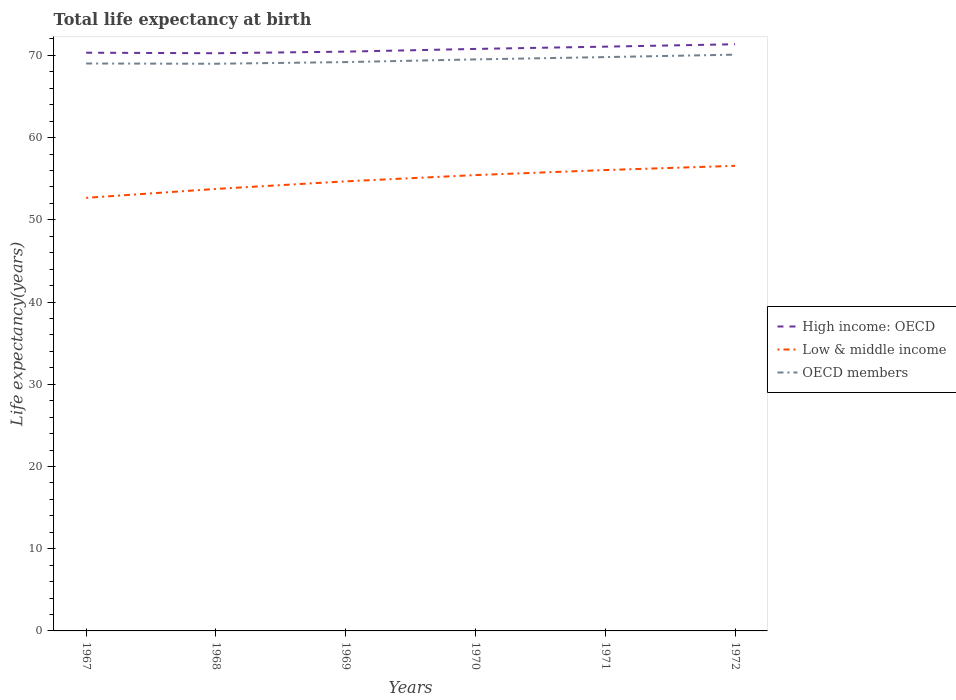Does the line corresponding to Low & middle income intersect with the line corresponding to OECD members?
Offer a terse response. No. Is the number of lines equal to the number of legend labels?
Give a very brief answer. Yes. Across all years, what is the maximum life expectancy at birth in in High income: OECD?
Your answer should be compact. 70.26. In which year was the life expectancy at birth in in OECD members maximum?
Give a very brief answer. 1968. What is the total life expectancy at birth in in OECD members in the graph?
Offer a very short reply. -0.78. What is the difference between the highest and the second highest life expectancy at birth in in OECD members?
Offer a very short reply. 1.11. What is the difference between the highest and the lowest life expectancy at birth in in Low & middle income?
Offer a terse response. 3. How many years are there in the graph?
Your answer should be compact. 6. Are the values on the major ticks of Y-axis written in scientific E-notation?
Your response must be concise. No. Where does the legend appear in the graph?
Give a very brief answer. Center right. What is the title of the graph?
Provide a succinct answer. Total life expectancy at birth. Does "Benin" appear as one of the legend labels in the graph?
Keep it short and to the point. No. What is the label or title of the Y-axis?
Your answer should be compact. Life expectancy(years). What is the Life expectancy(years) of High income: OECD in 1967?
Offer a terse response. 70.32. What is the Life expectancy(years) of Low & middle income in 1967?
Provide a succinct answer. 52.67. What is the Life expectancy(years) of OECD members in 1967?
Ensure brevity in your answer.  69.01. What is the Life expectancy(years) in High income: OECD in 1968?
Your response must be concise. 70.26. What is the Life expectancy(years) in Low & middle income in 1968?
Keep it short and to the point. 53.76. What is the Life expectancy(years) in OECD members in 1968?
Provide a succinct answer. 68.98. What is the Life expectancy(years) in High income: OECD in 1969?
Your answer should be compact. 70.45. What is the Life expectancy(years) of Low & middle income in 1969?
Provide a succinct answer. 54.68. What is the Life expectancy(years) of OECD members in 1969?
Ensure brevity in your answer.  69.18. What is the Life expectancy(years) of High income: OECD in 1970?
Offer a very short reply. 70.78. What is the Life expectancy(years) in Low & middle income in 1970?
Make the answer very short. 55.44. What is the Life expectancy(years) in OECD members in 1970?
Your answer should be compact. 69.51. What is the Life expectancy(years) in High income: OECD in 1971?
Make the answer very short. 71.06. What is the Life expectancy(years) in Low & middle income in 1971?
Offer a terse response. 56.05. What is the Life expectancy(years) in OECD members in 1971?
Make the answer very short. 69.79. What is the Life expectancy(years) of High income: OECD in 1972?
Your response must be concise. 71.35. What is the Life expectancy(years) of Low & middle income in 1972?
Your response must be concise. 56.57. What is the Life expectancy(years) of OECD members in 1972?
Provide a succinct answer. 70.09. Across all years, what is the maximum Life expectancy(years) of High income: OECD?
Make the answer very short. 71.35. Across all years, what is the maximum Life expectancy(years) in Low & middle income?
Your response must be concise. 56.57. Across all years, what is the maximum Life expectancy(years) of OECD members?
Provide a short and direct response. 70.09. Across all years, what is the minimum Life expectancy(years) of High income: OECD?
Your answer should be compact. 70.26. Across all years, what is the minimum Life expectancy(years) of Low & middle income?
Provide a succinct answer. 52.67. Across all years, what is the minimum Life expectancy(years) of OECD members?
Give a very brief answer. 68.98. What is the total Life expectancy(years) in High income: OECD in the graph?
Your answer should be very brief. 424.23. What is the total Life expectancy(years) in Low & middle income in the graph?
Give a very brief answer. 329.16. What is the total Life expectancy(years) in OECD members in the graph?
Make the answer very short. 416.56. What is the difference between the Life expectancy(years) in High income: OECD in 1967 and that in 1968?
Your answer should be very brief. 0.06. What is the difference between the Life expectancy(years) in Low & middle income in 1967 and that in 1968?
Your response must be concise. -1.08. What is the difference between the Life expectancy(years) of OECD members in 1967 and that in 1968?
Your response must be concise. 0.03. What is the difference between the Life expectancy(years) of High income: OECD in 1967 and that in 1969?
Provide a succinct answer. -0.13. What is the difference between the Life expectancy(years) in Low & middle income in 1967 and that in 1969?
Offer a very short reply. -2. What is the difference between the Life expectancy(years) in OECD members in 1967 and that in 1969?
Give a very brief answer. -0.17. What is the difference between the Life expectancy(years) of High income: OECD in 1967 and that in 1970?
Provide a short and direct response. -0.46. What is the difference between the Life expectancy(years) in Low & middle income in 1967 and that in 1970?
Provide a short and direct response. -2.77. What is the difference between the Life expectancy(years) in OECD members in 1967 and that in 1970?
Ensure brevity in your answer.  -0.5. What is the difference between the Life expectancy(years) of High income: OECD in 1967 and that in 1971?
Provide a succinct answer. -0.74. What is the difference between the Life expectancy(years) of Low & middle income in 1967 and that in 1971?
Your answer should be compact. -3.38. What is the difference between the Life expectancy(years) in OECD members in 1967 and that in 1971?
Make the answer very short. -0.78. What is the difference between the Life expectancy(years) in High income: OECD in 1967 and that in 1972?
Provide a short and direct response. -1.03. What is the difference between the Life expectancy(years) in Low & middle income in 1967 and that in 1972?
Provide a short and direct response. -3.89. What is the difference between the Life expectancy(years) of OECD members in 1967 and that in 1972?
Keep it short and to the point. -1.07. What is the difference between the Life expectancy(years) in High income: OECD in 1968 and that in 1969?
Provide a succinct answer. -0.19. What is the difference between the Life expectancy(years) of Low & middle income in 1968 and that in 1969?
Your answer should be compact. -0.92. What is the difference between the Life expectancy(years) of OECD members in 1968 and that in 1969?
Provide a short and direct response. -0.2. What is the difference between the Life expectancy(years) of High income: OECD in 1968 and that in 1970?
Keep it short and to the point. -0.52. What is the difference between the Life expectancy(years) of Low & middle income in 1968 and that in 1970?
Make the answer very short. -1.69. What is the difference between the Life expectancy(years) of OECD members in 1968 and that in 1970?
Keep it short and to the point. -0.53. What is the difference between the Life expectancy(years) of High income: OECD in 1968 and that in 1971?
Provide a short and direct response. -0.8. What is the difference between the Life expectancy(years) in Low & middle income in 1968 and that in 1971?
Your answer should be very brief. -2.3. What is the difference between the Life expectancy(years) of OECD members in 1968 and that in 1971?
Ensure brevity in your answer.  -0.81. What is the difference between the Life expectancy(years) of High income: OECD in 1968 and that in 1972?
Provide a succinct answer. -1.09. What is the difference between the Life expectancy(years) of Low & middle income in 1968 and that in 1972?
Ensure brevity in your answer.  -2.81. What is the difference between the Life expectancy(years) in OECD members in 1968 and that in 1972?
Provide a succinct answer. -1.11. What is the difference between the Life expectancy(years) of High income: OECD in 1969 and that in 1970?
Keep it short and to the point. -0.33. What is the difference between the Life expectancy(years) in Low & middle income in 1969 and that in 1970?
Offer a terse response. -0.76. What is the difference between the Life expectancy(years) in OECD members in 1969 and that in 1970?
Offer a terse response. -0.33. What is the difference between the Life expectancy(years) in High income: OECD in 1969 and that in 1971?
Ensure brevity in your answer.  -0.61. What is the difference between the Life expectancy(years) of Low & middle income in 1969 and that in 1971?
Provide a short and direct response. -1.37. What is the difference between the Life expectancy(years) in OECD members in 1969 and that in 1971?
Make the answer very short. -0.61. What is the difference between the Life expectancy(years) of High income: OECD in 1969 and that in 1972?
Give a very brief answer. -0.9. What is the difference between the Life expectancy(years) of Low & middle income in 1969 and that in 1972?
Keep it short and to the point. -1.89. What is the difference between the Life expectancy(years) of OECD members in 1969 and that in 1972?
Ensure brevity in your answer.  -0.9. What is the difference between the Life expectancy(years) of High income: OECD in 1970 and that in 1971?
Provide a succinct answer. -0.28. What is the difference between the Life expectancy(years) of Low & middle income in 1970 and that in 1971?
Offer a very short reply. -0.61. What is the difference between the Life expectancy(years) in OECD members in 1970 and that in 1971?
Your response must be concise. -0.28. What is the difference between the Life expectancy(years) of High income: OECD in 1970 and that in 1972?
Offer a terse response. -0.57. What is the difference between the Life expectancy(years) in Low & middle income in 1970 and that in 1972?
Make the answer very short. -1.12. What is the difference between the Life expectancy(years) of OECD members in 1970 and that in 1972?
Make the answer very short. -0.58. What is the difference between the Life expectancy(years) in High income: OECD in 1971 and that in 1972?
Provide a succinct answer. -0.29. What is the difference between the Life expectancy(years) of Low & middle income in 1971 and that in 1972?
Ensure brevity in your answer.  -0.51. What is the difference between the Life expectancy(years) in OECD members in 1971 and that in 1972?
Keep it short and to the point. -0.3. What is the difference between the Life expectancy(years) of High income: OECD in 1967 and the Life expectancy(years) of Low & middle income in 1968?
Offer a very short reply. 16.57. What is the difference between the Life expectancy(years) of High income: OECD in 1967 and the Life expectancy(years) of OECD members in 1968?
Give a very brief answer. 1.34. What is the difference between the Life expectancy(years) in Low & middle income in 1967 and the Life expectancy(years) in OECD members in 1968?
Give a very brief answer. -16.31. What is the difference between the Life expectancy(years) in High income: OECD in 1967 and the Life expectancy(years) in Low & middle income in 1969?
Ensure brevity in your answer.  15.65. What is the difference between the Life expectancy(years) in High income: OECD in 1967 and the Life expectancy(years) in OECD members in 1969?
Keep it short and to the point. 1.14. What is the difference between the Life expectancy(years) of Low & middle income in 1967 and the Life expectancy(years) of OECD members in 1969?
Offer a very short reply. -16.51. What is the difference between the Life expectancy(years) of High income: OECD in 1967 and the Life expectancy(years) of Low & middle income in 1970?
Your answer should be very brief. 14.88. What is the difference between the Life expectancy(years) in High income: OECD in 1967 and the Life expectancy(years) in OECD members in 1970?
Make the answer very short. 0.81. What is the difference between the Life expectancy(years) in Low & middle income in 1967 and the Life expectancy(years) in OECD members in 1970?
Your answer should be very brief. -16.84. What is the difference between the Life expectancy(years) in High income: OECD in 1967 and the Life expectancy(years) in Low & middle income in 1971?
Ensure brevity in your answer.  14.27. What is the difference between the Life expectancy(years) of High income: OECD in 1967 and the Life expectancy(years) of OECD members in 1971?
Keep it short and to the point. 0.53. What is the difference between the Life expectancy(years) of Low & middle income in 1967 and the Life expectancy(years) of OECD members in 1971?
Make the answer very short. -17.12. What is the difference between the Life expectancy(years) of High income: OECD in 1967 and the Life expectancy(years) of Low & middle income in 1972?
Give a very brief answer. 13.76. What is the difference between the Life expectancy(years) in High income: OECD in 1967 and the Life expectancy(years) in OECD members in 1972?
Provide a succinct answer. 0.24. What is the difference between the Life expectancy(years) of Low & middle income in 1967 and the Life expectancy(years) of OECD members in 1972?
Provide a short and direct response. -17.41. What is the difference between the Life expectancy(years) in High income: OECD in 1968 and the Life expectancy(years) in Low & middle income in 1969?
Your response must be concise. 15.58. What is the difference between the Life expectancy(years) in High income: OECD in 1968 and the Life expectancy(years) in OECD members in 1969?
Offer a very short reply. 1.08. What is the difference between the Life expectancy(years) in Low & middle income in 1968 and the Life expectancy(years) in OECD members in 1969?
Your answer should be compact. -15.43. What is the difference between the Life expectancy(years) of High income: OECD in 1968 and the Life expectancy(years) of Low & middle income in 1970?
Your answer should be compact. 14.82. What is the difference between the Life expectancy(years) of High income: OECD in 1968 and the Life expectancy(years) of OECD members in 1970?
Your response must be concise. 0.75. What is the difference between the Life expectancy(years) of Low & middle income in 1968 and the Life expectancy(years) of OECD members in 1970?
Ensure brevity in your answer.  -15.75. What is the difference between the Life expectancy(years) in High income: OECD in 1968 and the Life expectancy(years) in Low & middle income in 1971?
Provide a succinct answer. 14.21. What is the difference between the Life expectancy(years) of High income: OECD in 1968 and the Life expectancy(years) of OECD members in 1971?
Give a very brief answer. 0.47. What is the difference between the Life expectancy(years) in Low & middle income in 1968 and the Life expectancy(years) in OECD members in 1971?
Keep it short and to the point. -16.03. What is the difference between the Life expectancy(years) in High income: OECD in 1968 and the Life expectancy(years) in Low & middle income in 1972?
Provide a short and direct response. 13.7. What is the difference between the Life expectancy(years) of High income: OECD in 1968 and the Life expectancy(years) of OECD members in 1972?
Offer a very short reply. 0.18. What is the difference between the Life expectancy(years) of Low & middle income in 1968 and the Life expectancy(years) of OECD members in 1972?
Your response must be concise. -16.33. What is the difference between the Life expectancy(years) of High income: OECD in 1969 and the Life expectancy(years) of Low & middle income in 1970?
Offer a very short reply. 15.01. What is the difference between the Life expectancy(years) in High income: OECD in 1969 and the Life expectancy(years) in OECD members in 1970?
Ensure brevity in your answer.  0.94. What is the difference between the Life expectancy(years) of Low & middle income in 1969 and the Life expectancy(years) of OECD members in 1970?
Ensure brevity in your answer.  -14.83. What is the difference between the Life expectancy(years) in High income: OECD in 1969 and the Life expectancy(years) in Low & middle income in 1971?
Your answer should be very brief. 14.4. What is the difference between the Life expectancy(years) in High income: OECD in 1969 and the Life expectancy(years) in OECD members in 1971?
Ensure brevity in your answer.  0.66. What is the difference between the Life expectancy(years) of Low & middle income in 1969 and the Life expectancy(years) of OECD members in 1971?
Keep it short and to the point. -15.11. What is the difference between the Life expectancy(years) in High income: OECD in 1969 and the Life expectancy(years) in Low & middle income in 1972?
Give a very brief answer. 13.89. What is the difference between the Life expectancy(years) in High income: OECD in 1969 and the Life expectancy(years) in OECD members in 1972?
Ensure brevity in your answer.  0.37. What is the difference between the Life expectancy(years) in Low & middle income in 1969 and the Life expectancy(years) in OECD members in 1972?
Give a very brief answer. -15.41. What is the difference between the Life expectancy(years) in High income: OECD in 1970 and the Life expectancy(years) in Low & middle income in 1971?
Give a very brief answer. 14.73. What is the difference between the Life expectancy(years) in Low & middle income in 1970 and the Life expectancy(years) in OECD members in 1971?
Make the answer very short. -14.35. What is the difference between the Life expectancy(years) in High income: OECD in 1970 and the Life expectancy(years) in Low & middle income in 1972?
Give a very brief answer. 14.22. What is the difference between the Life expectancy(years) in High income: OECD in 1970 and the Life expectancy(years) in OECD members in 1972?
Make the answer very short. 0.7. What is the difference between the Life expectancy(years) in Low & middle income in 1970 and the Life expectancy(years) in OECD members in 1972?
Ensure brevity in your answer.  -14.65. What is the difference between the Life expectancy(years) in High income: OECD in 1971 and the Life expectancy(years) in Low & middle income in 1972?
Ensure brevity in your answer.  14.5. What is the difference between the Life expectancy(years) of High income: OECD in 1971 and the Life expectancy(years) of OECD members in 1972?
Your response must be concise. 0.98. What is the difference between the Life expectancy(years) of Low & middle income in 1971 and the Life expectancy(years) of OECD members in 1972?
Give a very brief answer. -14.03. What is the average Life expectancy(years) of High income: OECD per year?
Ensure brevity in your answer.  70.71. What is the average Life expectancy(years) of Low & middle income per year?
Offer a very short reply. 54.86. What is the average Life expectancy(years) in OECD members per year?
Keep it short and to the point. 69.43. In the year 1967, what is the difference between the Life expectancy(years) of High income: OECD and Life expectancy(years) of Low & middle income?
Provide a short and direct response. 17.65. In the year 1967, what is the difference between the Life expectancy(years) of High income: OECD and Life expectancy(years) of OECD members?
Offer a terse response. 1.31. In the year 1967, what is the difference between the Life expectancy(years) of Low & middle income and Life expectancy(years) of OECD members?
Your answer should be very brief. -16.34. In the year 1968, what is the difference between the Life expectancy(years) of High income: OECD and Life expectancy(years) of Low & middle income?
Give a very brief answer. 16.51. In the year 1968, what is the difference between the Life expectancy(years) in High income: OECD and Life expectancy(years) in OECD members?
Provide a short and direct response. 1.28. In the year 1968, what is the difference between the Life expectancy(years) of Low & middle income and Life expectancy(years) of OECD members?
Your answer should be compact. -15.23. In the year 1969, what is the difference between the Life expectancy(years) of High income: OECD and Life expectancy(years) of Low & middle income?
Give a very brief answer. 15.78. In the year 1969, what is the difference between the Life expectancy(years) of High income: OECD and Life expectancy(years) of OECD members?
Your response must be concise. 1.27. In the year 1969, what is the difference between the Life expectancy(years) of Low & middle income and Life expectancy(years) of OECD members?
Your answer should be very brief. -14.5. In the year 1970, what is the difference between the Life expectancy(years) in High income: OECD and Life expectancy(years) in Low & middle income?
Ensure brevity in your answer.  15.34. In the year 1970, what is the difference between the Life expectancy(years) of High income: OECD and Life expectancy(years) of OECD members?
Offer a terse response. 1.27. In the year 1970, what is the difference between the Life expectancy(years) of Low & middle income and Life expectancy(years) of OECD members?
Provide a succinct answer. -14.07. In the year 1971, what is the difference between the Life expectancy(years) in High income: OECD and Life expectancy(years) in Low & middle income?
Your response must be concise. 15.01. In the year 1971, what is the difference between the Life expectancy(years) of High income: OECD and Life expectancy(years) of OECD members?
Your answer should be very brief. 1.27. In the year 1971, what is the difference between the Life expectancy(years) of Low & middle income and Life expectancy(years) of OECD members?
Give a very brief answer. -13.74. In the year 1972, what is the difference between the Life expectancy(years) of High income: OECD and Life expectancy(years) of Low & middle income?
Provide a succinct answer. 14.79. In the year 1972, what is the difference between the Life expectancy(years) of High income: OECD and Life expectancy(years) of OECD members?
Offer a terse response. 1.27. In the year 1972, what is the difference between the Life expectancy(years) in Low & middle income and Life expectancy(years) in OECD members?
Your response must be concise. -13.52. What is the ratio of the Life expectancy(years) of High income: OECD in 1967 to that in 1968?
Provide a short and direct response. 1. What is the ratio of the Life expectancy(years) in Low & middle income in 1967 to that in 1968?
Give a very brief answer. 0.98. What is the ratio of the Life expectancy(years) of OECD members in 1967 to that in 1968?
Your answer should be very brief. 1. What is the ratio of the Life expectancy(years) in High income: OECD in 1967 to that in 1969?
Offer a terse response. 1. What is the ratio of the Life expectancy(years) of Low & middle income in 1967 to that in 1969?
Your response must be concise. 0.96. What is the ratio of the Life expectancy(years) of High income: OECD in 1967 to that in 1970?
Ensure brevity in your answer.  0.99. What is the ratio of the Life expectancy(years) in Low & middle income in 1967 to that in 1970?
Provide a short and direct response. 0.95. What is the ratio of the Life expectancy(years) of OECD members in 1967 to that in 1970?
Make the answer very short. 0.99. What is the ratio of the Life expectancy(years) in High income: OECD in 1967 to that in 1971?
Ensure brevity in your answer.  0.99. What is the ratio of the Life expectancy(years) in Low & middle income in 1967 to that in 1971?
Ensure brevity in your answer.  0.94. What is the ratio of the Life expectancy(years) of OECD members in 1967 to that in 1971?
Make the answer very short. 0.99. What is the ratio of the Life expectancy(years) in High income: OECD in 1967 to that in 1972?
Ensure brevity in your answer.  0.99. What is the ratio of the Life expectancy(years) in Low & middle income in 1967 to that in 1972?
Your answer should be very brief. 0.93. What is the ratio of the Life expectancy(years) of OECD members in 1967 to that in 1972?
Offer a very short reply. 0.98. What is the ratio of the Life expectancy(years) of High income: OECD in 1968 to that in 1969?
Give a very brief answer. 1. What is the ratio of the Life expectancy(years) in Low & middle income in 1968 to that in 1969?
Provide a succinct answer. 0.98. What is the ratio of the Life expectancy(years) in High income: OECD in 1968 to that in 1970?
Your response must be concise. 0.99. What is the ratio of the Life expectancy(years) in Low & middle income in 1968 to that in 1970?
Your answer should be compact. 0.97. What is the ratio of the Life expectancy(years) in OECD members in 1968 to that in 1970?
Provide a succinct answer. 0.99. What is the ratio of the Life expectancy(years) of High income: OECD in 1968 to that in 1971?
Make the answer very short. 0.99. What is the ratio of the Life expectancy(years) of Low & middle income in 1968 to that in 1971?
Make the answer very short. 0.96. What is the ratio of the Life expectancy(years) in OECD members in 1968 to that in 1971?
Provide a succinct answer. 0.99. What is the ratio of the Life expectancy(years) of High income: OECD in 1968 to that in 1972?
Make the answer very short. 0.98. What is the ratio of the Life expectancy(years) in Low & middle income in 1968 to that in 1972?
Provide a succinct answer. 0.95. What is the ratio of the Life expectancy(years) of OECD members in 1968 to that in 1972?
Your answer should be compact. 0.98. What is the ratio of the Life expectancy(years) in Low & middle income in 1969 to that in 1970?
Your response must be concise. 0.99. What is the ratio of the Life expectancy(years) of OECD members in 1969 to that in 1970?
Offer a terse response. 1. What is the ratio of the Life expectancy(years) in Low & middle income in 1969 to that in 1971?
Offer a very short reply. 0.98. What is the ratio of the Life expectancy(years) in High income: OECD in 1969 to that in 1972?
Make the answer very short. 0.99. What is the ratio of the Life expectancy(years) in Low & middle income in 1969 to that in 1972?
Provide a short and direct response. 0.97. What is the ratio of the Life expectancy(years) of OECD members in 1969 to that in 1972?
Give a very brief answer. 0.99. What is the ratio of the Life expectancy(years) in Low & middle income in 1970 to that in 1971?
Offer a terse response. 0.99. What is the ratio of the Life expectancy(years) of OECD members in 1970 to that in 1971?
Make the answer very short. 1. What is the ratio of the Life expectancy(years) of High income: OECD in 1970 to that in 1972?
Your response must be concise. 0.99. What is the ratio of the Life expectancy(years) of Low & middle income in 1970 to that in 1972?
Provide a short and direct response. 0.98. What is the ratio of the Life expectancy(years) in Low & middle income in 1971 to that in 1972?
Provide a short and direct response. 0.99. What is the ratio of the Life expectancy(years) of OECD members in 1971 to that in 1972?
Ensure brevity in your answer.  1. What is the difference between the highest and the second highest Life expectancy(years) in High income: OECD?
Your answer should be very brief. 0.29. What is the difference between the highest and the second highest Life expectancy(years) of Low & middle income?
Your answer should be compact. 0.51. What is the difference between the highest and the second highest Life expectancy(years) of OECD members?
Your response must be concise. 0.3. What is the difference between the highest and the lowest Life expectancy(years) of High income: OECD?
Give a very brief answer. 1.09. What is the difference between the highest and the lowest Life expectancy(years) of Low & middle income?
Make the answer very short. 3.89. What is the difference between the highest and the lowest Life expectancy(years) of OECD members?
Offer a very short reply. 1.11. 